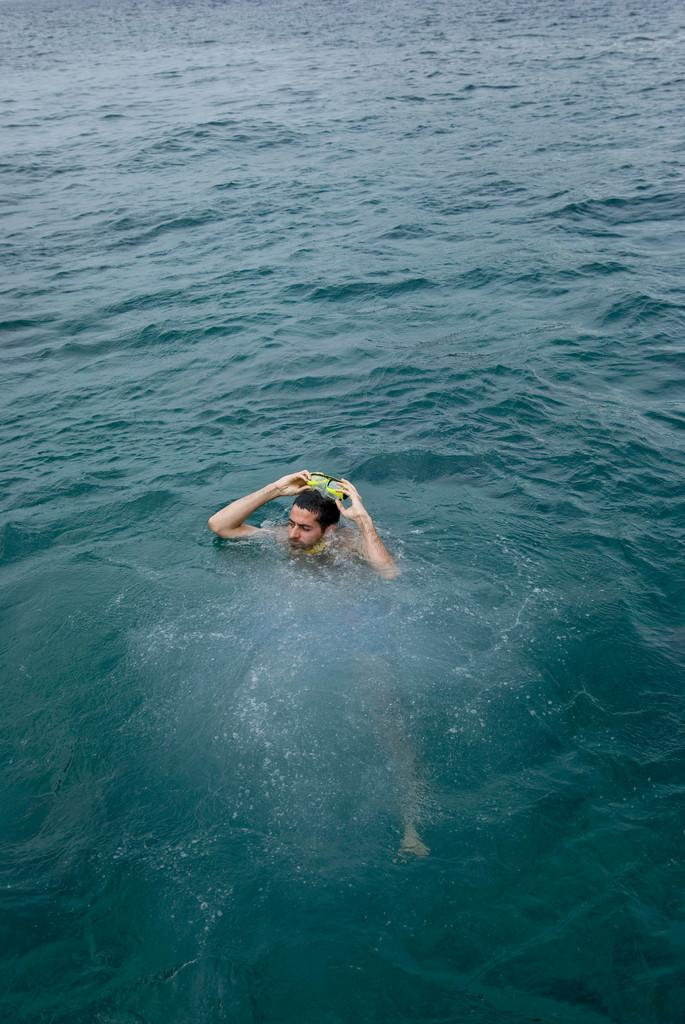What is the person in the image doing? There is a person in the water in the image. What type of equipment is the person wearing? The person is wearing swimming goggles. What type of laborer is depicted in the image? There is no laborer present in the image; it features a person in the water wearing swimming goggles. What degree does the person in the image hold? There is no indication of the person's educational background or any degrees in the image. 